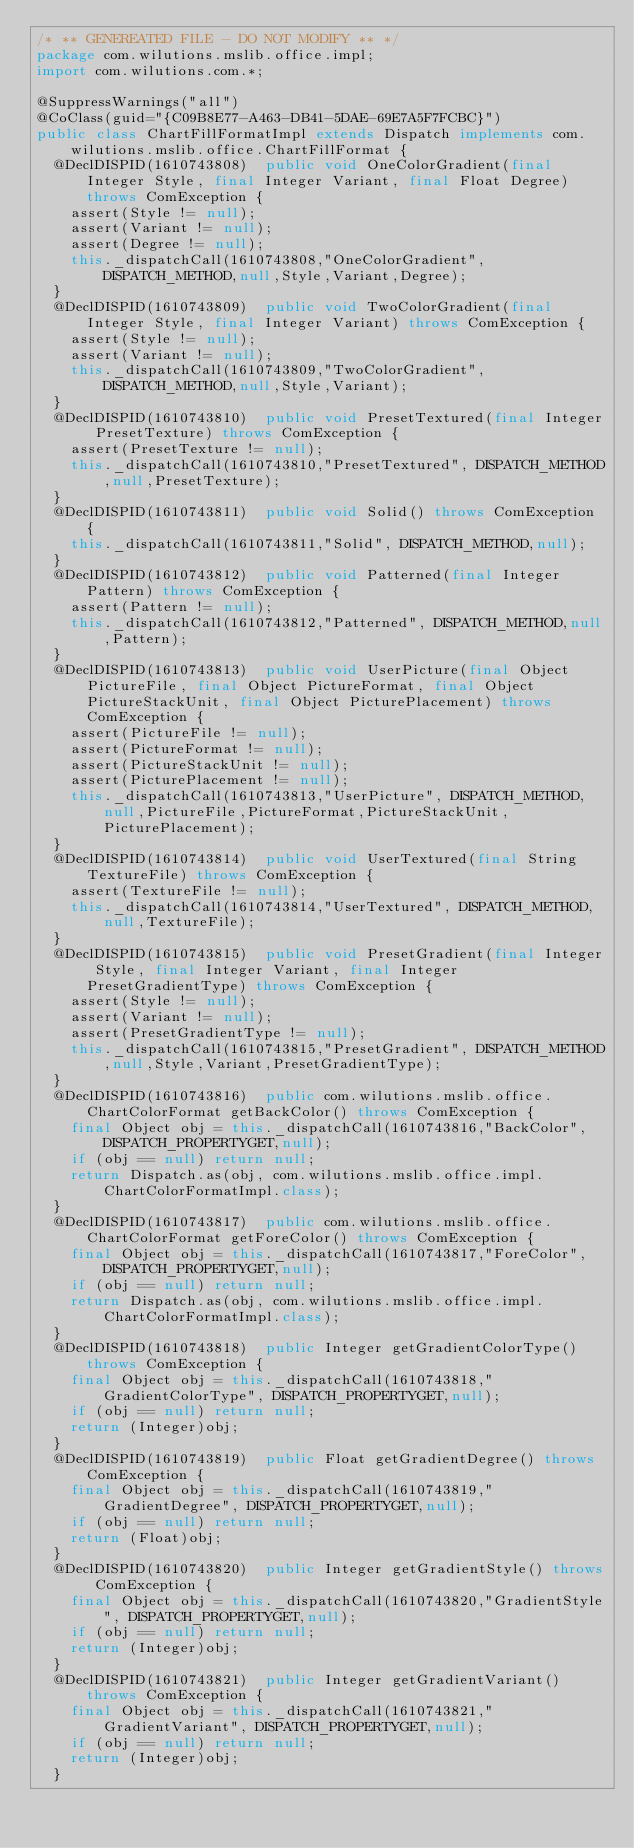<code> <loc_0><loc_0><loc_500><loc_500><_Java_>/* ** GENEREATED FILE - DO NOT MODIFY ** */
package com.wilutions.mslib.office.impl;
import com.wilutions.com.*;

@SuppressWarnings("all")
@CoClass(guid="{C09B8E77-A463-DB41-5DAE-69E7A5F7FCBC}")
public class ChartFillFormatImpl extends Dispatch implements com.wilutions.mslib.office.ChartFillFormat {
  @DeclDISPID(1610743808)  public void OneColorGradient(final Integer Style, final Integer Variant, final Float Degree) throws ComException {
    assert(Style != null);
    assert(Variant != null);
    assert(Degree != null);
    this._dispatchCall(1610743808,"OneColorGradient", DISPATCH_METHOD,null,Style,Variant,Degree);
  }
  @DeclDISPID(1610743809)  public void TwoColorGradient(final Integer Style, final Integer Variant) throws ComException {
    assert(Style != null);
    assert(Variant != null);
    this._dispatchCall(1610743809,"TwoColorGradient", DISPATCH_METHOD,null,Style,Variant);
  }
  @DeclDISPID(1610743810)  public void PresetTextured(final Integer PresetTexture) throws ComException {
    assert(PresetTexture != null);
    this._dispatchCall(1610743810,"PresetTextured", DISPATCH_METHOD,null,PresetTexture);
  }
  @DeclDISPID(1610743811)  public void Solid() throws ComException {
    this._dispatchCall(1610743811,"Solid", DISPATCH_METHOD,null);
  }
  @DeclDISPID(1610743812)  public void Patterned(final Integer Pattern) throws ComException {
    assert(Pattern != null);
    this._dispatchCall(1610743812,"Patterned", DISPATCH_METHOD,null,Pattern);
  }
  @DeclDISPID(1610743813)  public void UserPicture(final Object PictureFile, final Object PictureFormat, final Object PictureStackUnit, final Object PicturePlacement) throws ComException {
    assert(PictureFile != null);
    assert(PictureFormat != null);
    assert(PictureStackUnit != null);
    assert(PicturePlacement != null);
    this._dispatchCall(1610743813,"UserPicture", DISPATCH_METHOD,null,PictureFile,PictureFormat,PictureStackUnit,PicturePlacement);
  }
  @DeclDISPID(1610743814)  public void UserTextured(final String TextureFile) throws ComException {
    assert(TextureFile != null);
    this._dispatchCall(1610743814,"UserTextured", DISPATCH_METHOD,null,TextureFile);
  }
  @DeclDISPID(1610743815)  public void PresetGradient(final Integer Style, final Integer Variant, final Integer PresetGradientType) throws ComException {
    assert(Style != null);
    assert(Variant != null);
    assert(PresetGradientType != null);
    this._dispatchCall(1610743815,"PresetGradient", DISPATCH_METHOD,null,Style,Variant,PresetGradientType);
  }
  @DeclDISPID(1610743816)  public com.wilutions.mslib.office.ChartColorFormat getBackColor() throws ComException {
    final Object obj = this._dispatchCall(1610743816,"BackColor", DISPATCH_PROPERTYGET,null);
    if (obj == null) return null;
    return Dispatch.as(obj, com.wilutions.mslib.office.impl.ChartColorFormatImpl.class);
  }
  @DeclDISPID(1610743817)  public com.wilutions.mslib.office.ChartColorFormat getForeColor() throws ComException {
    final Object obj = this._dispatchCall(1610743817,"ForeColor", DISPATCH_PROPERTYGET,null);
    if (obj == null) return null;
    return Dispatch.as(obj, com.wilutions.mslib.office.impl.ChartColorFormatImpl.class);
  }
  @DeclDISPID(1610743818)  public Integer getGradientColorType() throws ComException {
    final Object obj = this._dispatchCall(1610743818,"GradientColorType", DISPATCH_PROPERTYGET,null);
    if (obj == null) return null;
    return (Integer)obj;
  }
  @DeclDISPID(1610743819)  public Float getGradientDegree() throws ComException {
    final Object obj = this._dispatchCall(1610743819,"GradientDegree", DISPATCH_PROPERTYGET,null);
    if (obj == null) return null;
    return (Float)obj;
  }
  @DeclDISPID(1610743820)  public Integer getGradientStyle() throws ComException {
    final Object obj = this._dispatchCall(1610743820,"GradientStyle", DISPATCH_PROPERTYGET,null);
    if (obj == null) return null;
    return (Integer)obj;
  }
  @DeclDISPID(1610743821)  public Integer getGradientVariant() throws ComException {
    final Object obj = this._dispatchCall(1610743821,"GradientVariant", DISPATCH_PROPERTYGET,null);
    if (obj == null) return null;
    return (Integer)obj;
  }</code> 